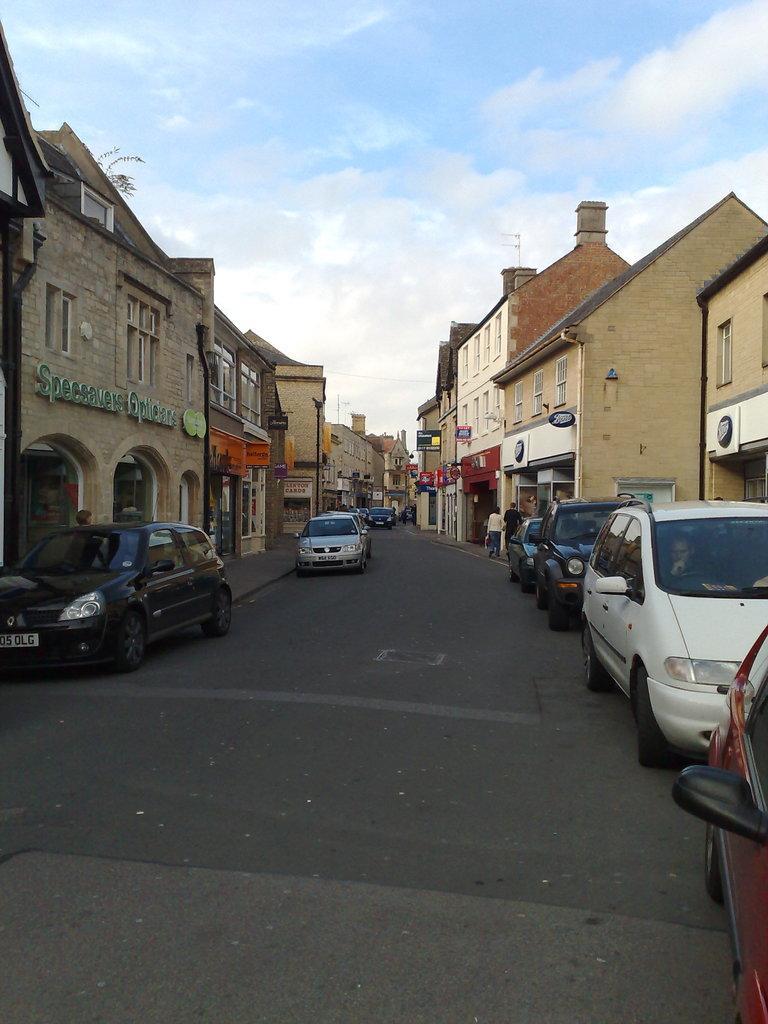Could you give a brief overview of what you see in this image? In the center of the image there is a road and we can see cars on the road. In the background there are people, buildings and sky. 